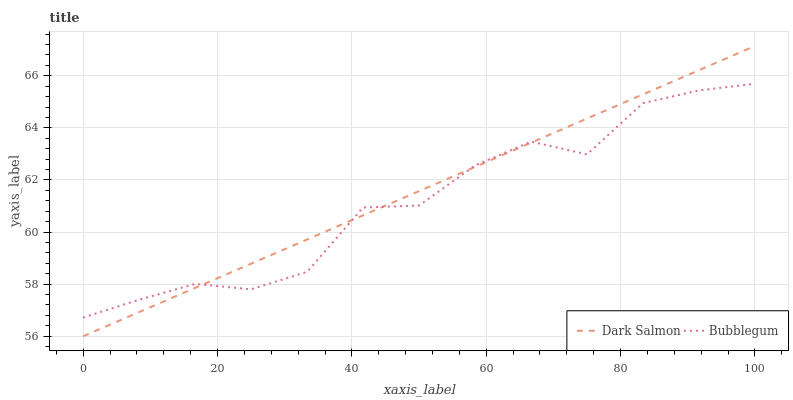Does Bubblegum have the minimum area under the curve?
Answer yes or no. Yes. Does Dark Salmon have the maximum area under the curve?
Answer yes or no. Yes. Does Bubblegum have the maximum area under the curve?
Answer yes or no. No. Is Dark Salmon the smoothest?
Answer yes or no. Yes. Is Bubblegum the roughest?
Answer yes or no. Yes. Is Bubblegum the smoothest?
Answer yes or no. No. Does Bubblegum have the lowest value?
Answer yes or no. No. Does Dark Salmon have the highest value?
Answer yes or no. Yes. Does Bubblegum have the highest value?
Answer yes or no. No. Does Dark Salmon intersect Bubblegum?
Answer yes or no. Yes. Is Dark Salmon less than Bubblegum?
Answer yes or no. No. Is Dark Salmon greater than Bubblegum?
Answer yes or no. No. 